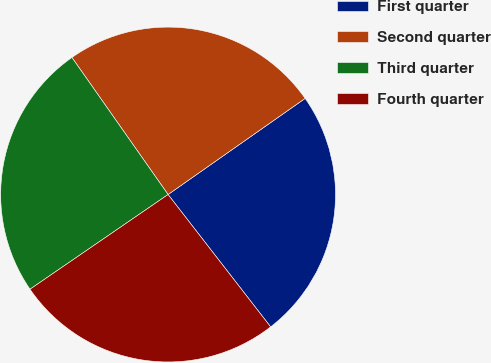Convert chart to OTSL. <chart><loc_0><loc_0><loc_500><loc_500><pie_chart><fcel>First quarter<fcel>Second quarter<fcel>Third quarter<fcel>Fourth quarter<nl><fcel>24.24%<fcel>25.0%<fcel>24.83%<fcel>25.92%<nl></chart> 